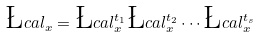<formula> <loc_0><loc_0><loc_500><loc_500>\L c a l _ { x } = \L c a l _ { x } ^ { t _ { 1 } } \L c a l _ { x } ^ { t _ { 2 } } \cdots \L c a l _ { x } ^ { t _ { s } }</formula> 